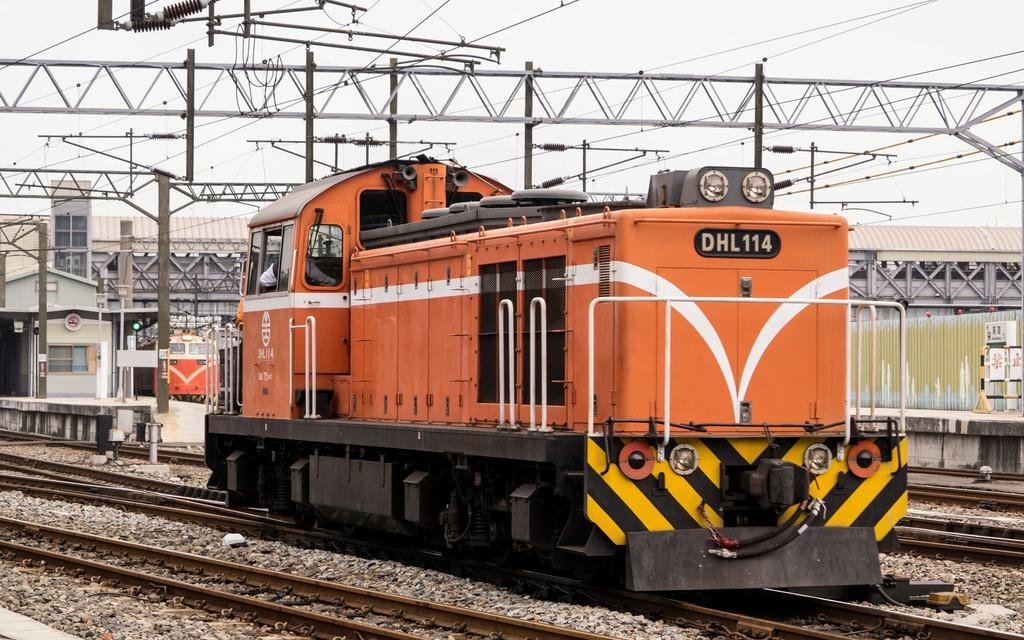What is the main subject of the image? The main subject of the image is a train engine. Where is the train engine located in the image? The train engine is on a track in the image. What else can be seen in the image related to the train? There are train tracks visible in the image. What structures are present in the image related to electricity? Electric poles and electric wires are present in the image. What type of stationary structure is in the image? There is a platform in the image. What type of natural element is present in the image? Stones are present in the image. What part of the environment is visible in the image? The sky is visible in the image. What type of action is the wing performing in the image? There is no wing present in the image; it features a train engine on a track. 